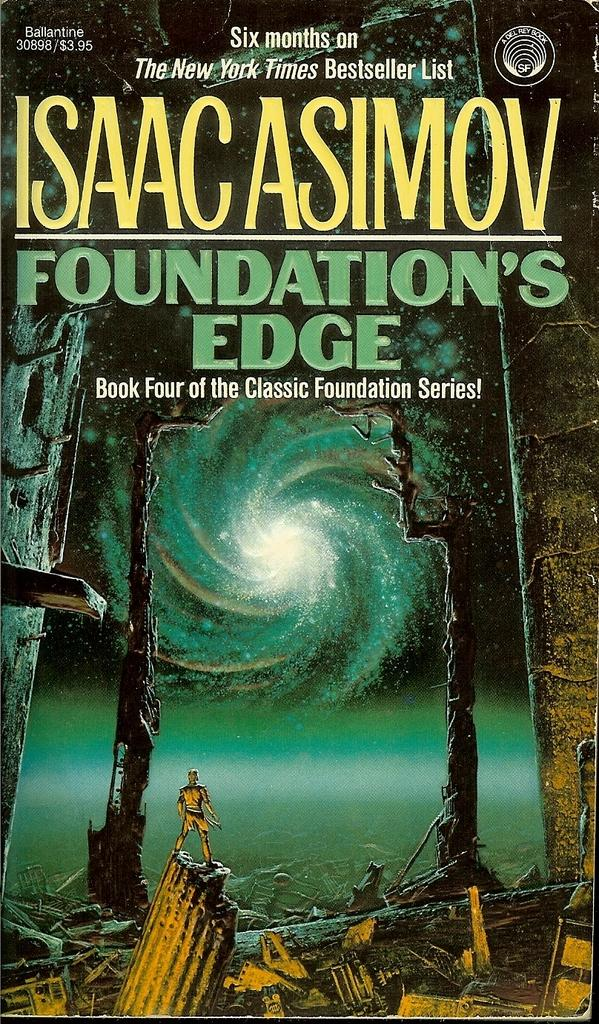<image>
Describe the image concisely. The cover of Isaac Asimov's book, Foundation's edge states that it was on the New York Times Bestseller list for six months. 